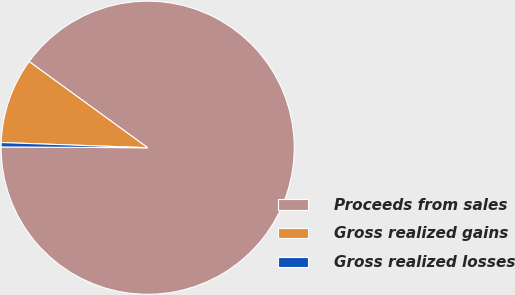Convert chart to OTSL. <chart><loc_0><loc_0><loc_500><loc_500><pie_chart><fcel>Proceeds from sales<fcel>Gross realized gains<fcel>Gross realized losses<nl><fcel>90.08%<fcel>9.44%<fcel>0.48%<nl></chart> 